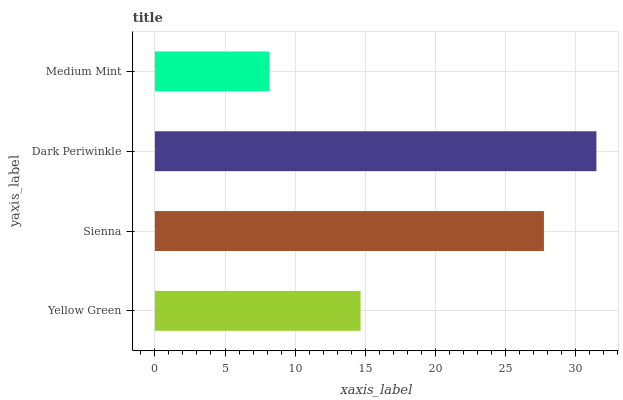Is Medium Mint the minimum?
Answer yes or no. Yes. Is Dark Periwinkle the maximum?
Answer yes or no. Yes. Is Sienna the minimum?
Answer yes or no. No. Is Sienna the maximum?
Answer yes or no. No. Is Sienna greater than Yellow Green?
Answer yes or no. Yes. Is Yellow Green less than Sienna?
Answer yes or no. Yes. Is Yellow Green greater than Sienna?
Answer yes or no. No. Is Sienna less than Yellow Green?
Answer yes or no. No. Is Sienna the high median?
Answer yes or no. Yes. Is Yellow Green the low median?
Answer yes or no. Yes. Is Dark Periwinkle the high median?
Answer yes or no. No. Is Dark Periwinkle the low median?
Answer yes or no. No. 